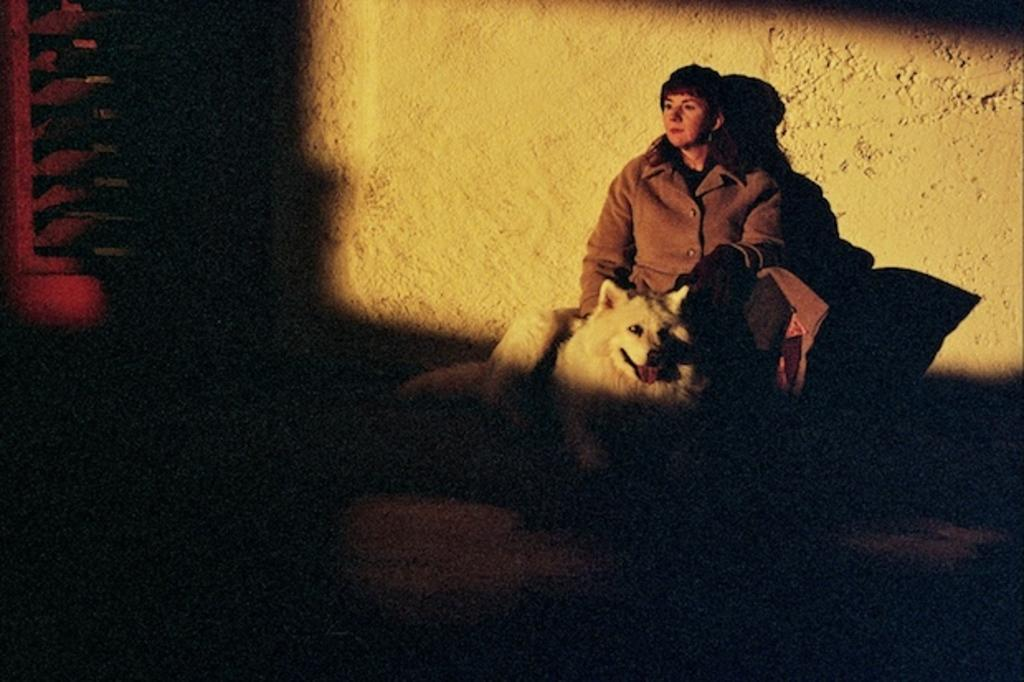Who is present in the image? There is a woman in the image. What animal is with the woman? The woman is accompanied by a white dog. What type of clothing is the woman wearing? The woman is wearing a brown jacket. What is the woman's opinion on the sheet in the image? There is no sheet present in the image, so it is not possible to determine the woman's opinion on it. 